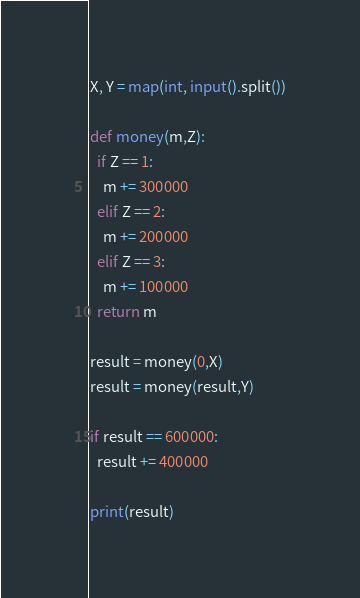<code> <loc_0><loc_0><loc_500><loc_500><_Python_>X, Y = map(int, input().split())

def money(m,Z):
  if Z == 1:
    m += 300000
  elif Z == 2:
    m += 200000
  elif Z == 3:
    m += 100000
  return m

result = money(0,X)
result = money(result,Y)

if result == 600000:
  result += 400000

print(result)</code> 